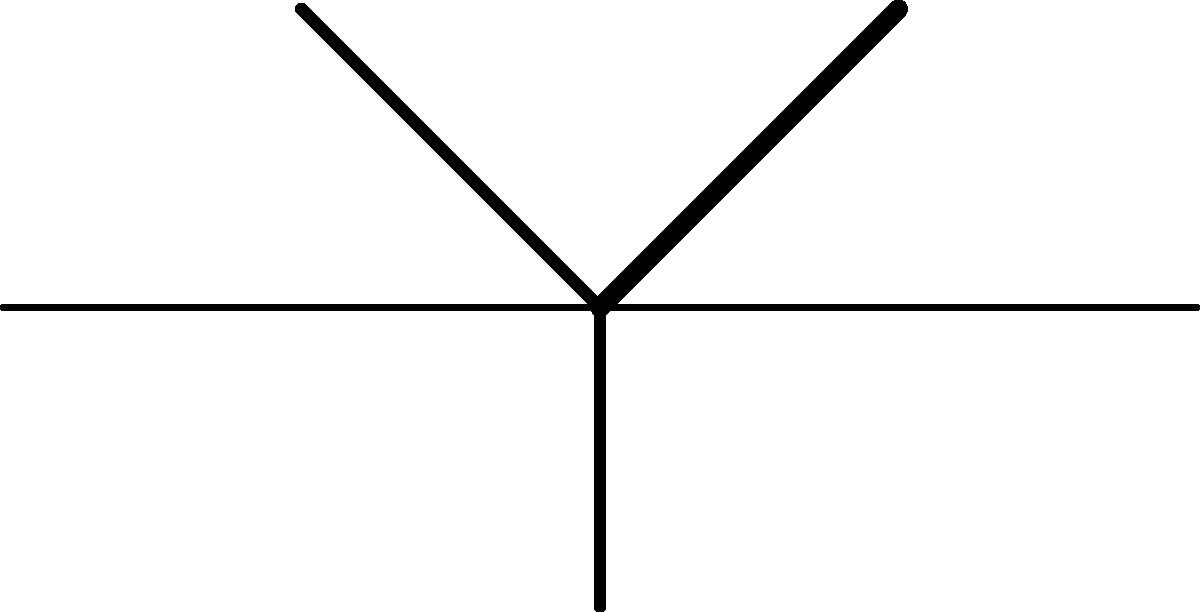Based on the network diagram representing Julio Iglesias's collaborations, which artist has he collaborated with most frequently, and how does this reflect his career trajectory and musical influences? To answer this question, we need to analyze the network diagram step by step:

1. The diagram shows Julio Iglesias at the center, connected to five other artists.

2. The thickness of the lines represents the frequency of collaborations:
   - Thickest line: Julio Iglesias - Frank Sinatra
   - Medium thick lines: Julio Iglesias - Willie Nelson, Julio Iglesias - Diana Ross
   - Thinnest lines: Julio Iglesias - Stevie Wonder, Julio Iglesias - Dolly Parton

3. Based on the line thickness, Frank Sinatra is the artist Julio Iglesias has collaborated with most frequently.

4. This collaboration frequency reflects Iglesias's career trajectory and musical influences:
   a) Frank Sinatra: Represents Iglesias's connection to classic American pop and his crossover appeal to English-speaking audiences.
   b) Willie Nelson: Indicates Iglesias's foray into country music and his ability to bridge different musical genres.
   c) Diana Ross: Showcases Iglesias's collaborations with prominent American R&B and pop artists.
   d) Stevie Wonder and Dolly Parton: While less frequent, these collaborations demonstrate Iglesias's versatility and ability to work with diverse artists across different genres.

5. The variety of collaborators reflects Iglesias's international appeal and his ability to adapt to different musical styles, from pop and country to R&B and soul.

6. The frequency of collaborations, particularly with Frank Sinatra, highlights Iglesias's status as a global superstar and his acceptance by established American artists.
Answer: Frank Sinatra; reflects Iglesias's crossover to American pop and international stardom. 